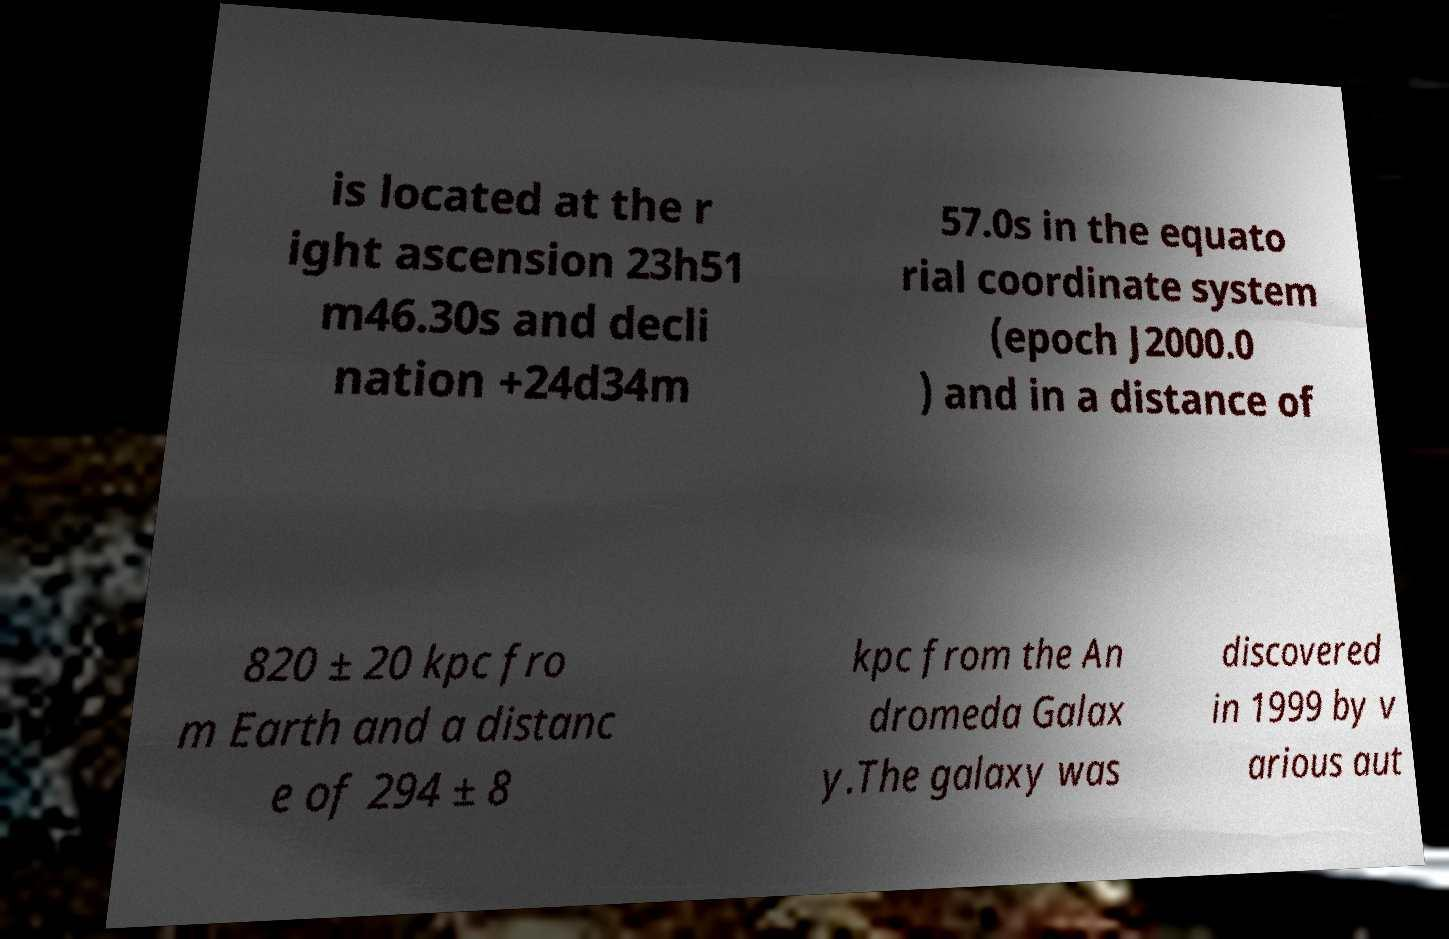Please read and relay the text visible in this image. What does it say? is located at the r ight ascension 23h51 m46.30s and decli nation +24d34m 57.0s in the equato rial coordinate system (epoch J2000.0 ) and in a distance of 820 ± 20 kpc fro m Earth and a distanc e of 294 ± 8 kpc from the An dromeda Galax y.The galaxy was discovered in 1999 by v arious aut 